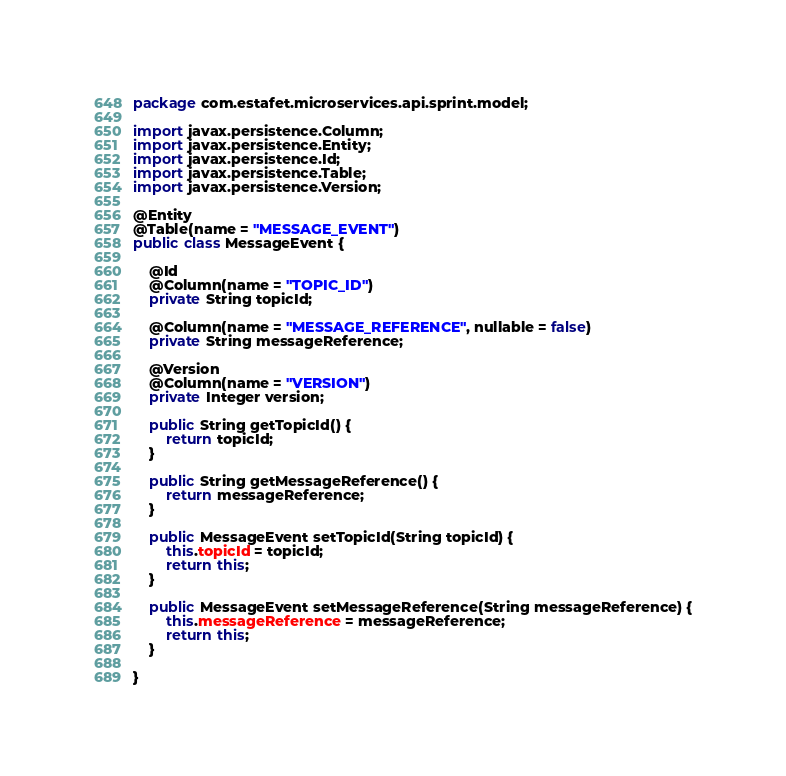Convert code to text. <code><loc_0><loc_0><loc_500><loc_500><_Java_>package com.estafet.microservices.api.sprint.model;

import javax.persistence.Column;
import javax.persistence.Entity;
import javax.persistence.Id;
import javax.persistence.Table;
import javax.persistence.Version;

@Entity
@Table(name = "MESSAGE_EVENT")
public class MessageEvent {

	@Id
	@Column(name = "TOPIC_ID")
	private String topicId;

	@Column(name = "MESSAGE_REFERENCE", nullable = false)
	private String messageReference;
	
	@Version
	@Column(name = "VERSION")
	private Integer version;

	public String getTopicId() {
		return topicId;
	}

	public String getMessageReference() {
		return messageReference;
	}

	public MessageEvent setTopicId(String topicId) {
		this.topicId = topicId;
		return this;
	}

	public MessageEvent setMessageReference(String messageReference) {
		this.messageReference = messageReference;
		return this;
	}

}
</code> 